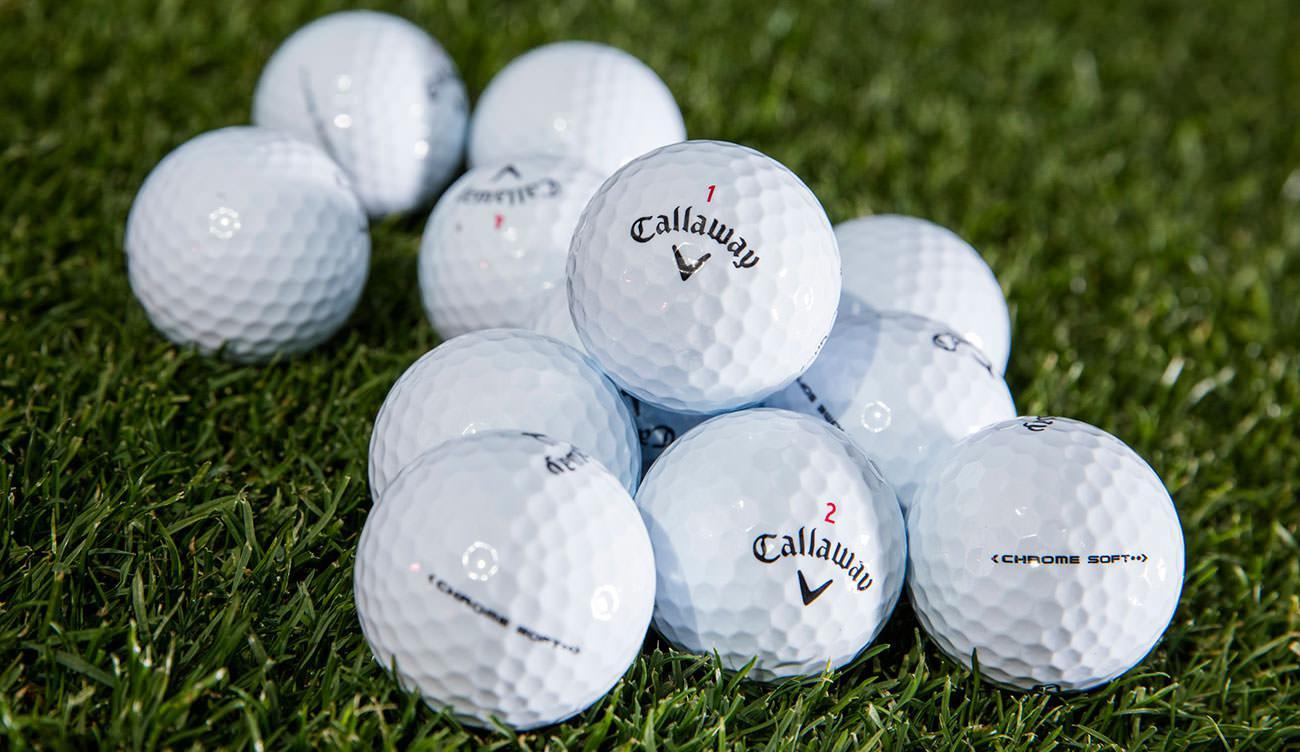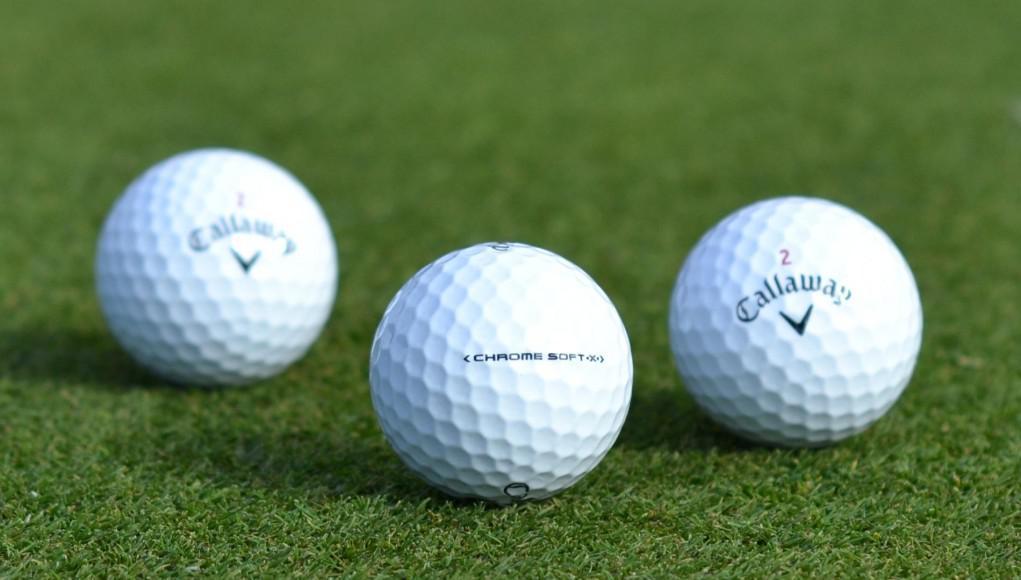The first image is the image on the left, the second image is the image on the right. For the images displayed, is the sentence "there are exactly three balls in one of the images." factually correct? Answer yes or no. Yes. 